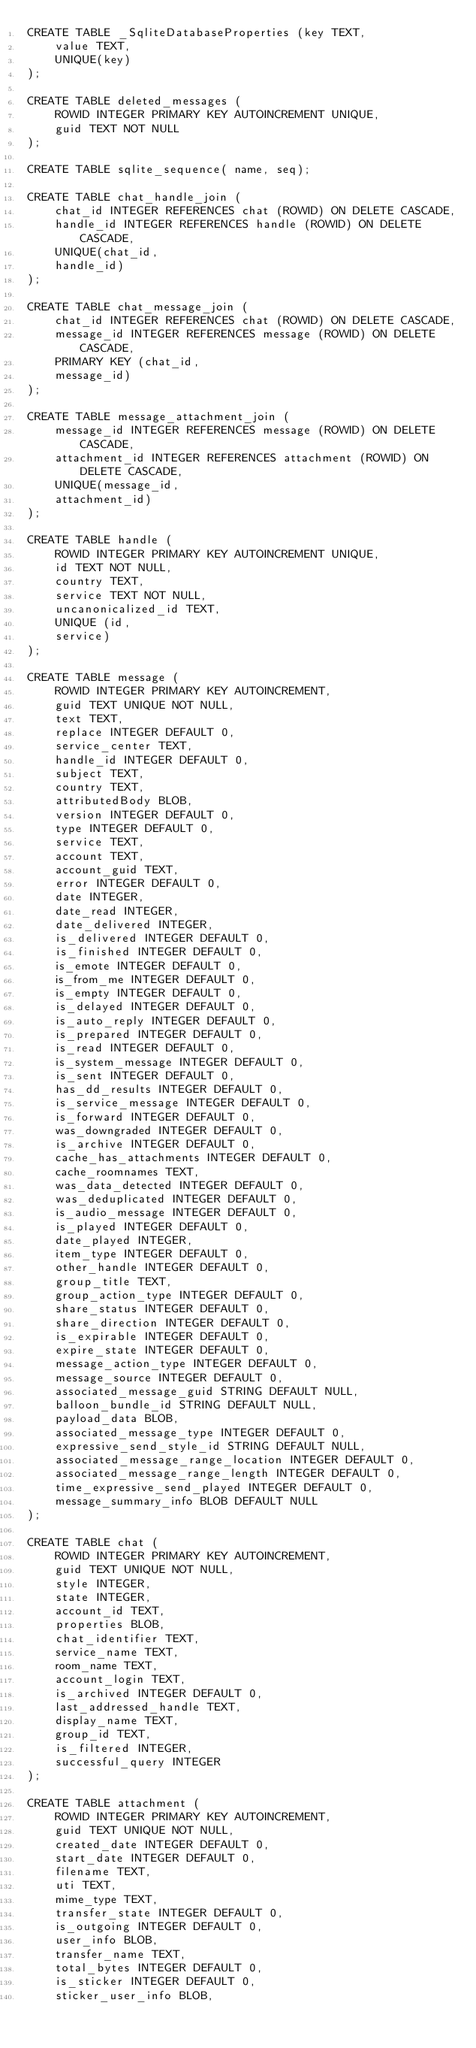Convert code to text. <code><loc_0><loc_0><loc_500><loc_500><_SQL_>CREATE TABLE _SqliteDatabaseProperties (key TEXT,
    value TEXT,
    UNIQUE(key)
);

CREATE TABLE deleted_messages (
    ROWID INTEGER PRIMARY KEY AUTOINCREMENT UNIQUE,
    guid TEXT NOT NULL
);

CREATE TABLE sqlite_sequence( name, seq);

CREATE TABLE chat_handle_join (
    chat_id INTEGER REFERENCES chat (ROWID) ON DELETE CASCADE,
    handle_id INTEGER REFERENCES handle (ROWID) ON DELETE CASCADE,
    UNIQUE(chat_id,
    handle_id)
);

CREATE TABLE chat_message_join (
    chat_id INTEGER REFERENCES chat (ROWID) ON DELETE CASCADE,
    message_id INTEGER REFERENCES message (ROWID) ON DELETE CASCADE,
    PRIMARY KEY (chat_id,
    message_id)
);

CREATE TABLE message_attachment_join (
    message_id INTEGER REFERENCES message (ROWID) ON DELETE CASCADE,
    attachment_id INTEGER REFERENCES attachment (ROWID) ON DELETE CASCADE,
    UNIQUE(message_id,
    attachment_id)
);

CREATE TABLE handle (
    ROWID INTEGER PRIMARY KEY AUTOINCREMENT UNIQUE,
    id TEXT NOT NULL,
    country TEXT,
    service TEXT NOT NULL,
    uncanonicalized_id TEXT,
    UNIQUE (id,
    service) 
);

CREATE TABLE message (
    ROWID INTEGER PRIMARY KEY AUTOINCREMENT,
    guid TEXT UNIQUE NOT NULL,
    text TEXT,
    replace INTEGER DEFAULT 0,
    service_center TEXT,
    handle_id INTEGER DEFAULT 0,
    subject TEXT,
    country TEXT,
    attributedBody BLOB,
    version INTEGER DEFAULT 0,
    type INTEGER DEFAULT 0,
    service TEXT,
    account TEXT,
    account_guid TEXT,
    error INTEGER DEFAULT 0,
    date INTEGER,
    date_read INTEGER,
    date_delivered INTEGER,
    is_delivered INTEGER DEFAULT 0,
    is_finished INTEGER DEFAULT 0,
    is_emote INTEGER DEFAULT 0,
    is_from_me INTEGER DEFAULT 0,
    is_empty INTEGER DEFAULT 0,
    is_delayed INTEGER DEFAULT 0,
    is_auto_reply INTEGER DEFAULT 0,
    is_prepared INTEGER DEFAULT 0,
    is_read INTEGER DEFAULT 0,
    is_system_message INTEGER DEFAULT 0,
    is_sent INTEGER DEFAULT 0,
    has_dd_results INTEGER DEFAULT 0,
    is_service_message INTEGER DEFAULT 0,
    is_forward INTEGER DEFAULT 0,
    was_downgraded INTEGER DEFAULT 0,
    is_archive INTEGER DEFAULT 0,
    cache_has_attachments INTEGER DEFAULT 0,
    cache_roomnames TEXT,
    was_data_detected INTEGER DEFAULT 0,
    was_deduplicated INTEGER DEFAULT 0,
    is_audio_message INTEGER DEFAULT 0,
    is_played INTEGER DEFAULT 0,
    date_played INTEGER,
    item_type INTEGER DEFAULT 0,
    other_handle INTEGER DEFAULT 0,
    group_title TEXT,
    group_action_type INTEGER DEFAULT 0,
    share_status INTEGER DEFAULT 0,
    share_direction INTEGER DEFAULT 0,
    is_expirable INTEGER DEFAULT 0,
    expire_state INTEGER DEFAULT 0,
    message_action_type INTEGER DEFAULT 0,
    message_source INTEGER DEFAULT 0,
    associated_message_guid STRING DEFAULT NULL,
    balloon_bundle_id STRING DEFAULT NULL,
    payload_data BLOB,
    associated_message_type INTEGER DEFAULT 0,
    expressive_send_style_id STRING DEFAULT NULL,
    associated_message_range_location INTEGER DEFAULT 0,
    associated_message_range_length INTEGER DEFAULT 0,
    time_expressive_send_played INTEGER DEFAULT 0,
    message_summary_info BLOB DEFAULT NULL
);

CREATE TABLE chat (
    ROWID INTEGER PRIMARY KEY AUTOINCREMENT,
    guid TEXT UNIQUE NOT NULL,
    style INTEGER,
    state INTEGER,
    account_id TEXT,
    properties BLOB,
    chat_identifier TEXT,
    service_name TEXT,
    room_name TEXT,
    account_login TEXT,
    is_archived INTEGER DEFAULT 0,
    last_addressed_handle TEXT,
    display_name TEXT,
    group_id TEXT,
    is_filtered INTEGER,
    successful_query INTEGER
);

CREATE TABLE attachment (
    ROWID INTEGER PRIMARY KEY AUTOINCREMENT,
    guid TEXT UNIQUE NOT NULL,
    created_date INTEGER DEFAULT 0,
    start_date INTEGER DEFAULT 0,
    filename TEXT,
    uti TEXT,
    mime_type TEXT,
    transfer_state INTEGER DEFAULT 0,
    is_outgoing INTEGER DEFAULT 0,
    user_info BLOB,
    transfer_name TEXT,
    total_bytes INTEGER DEFAULT 0,
    is_sticker INTEGER DEFAULT 0,
    sticker_user_info BLOB,</code> 